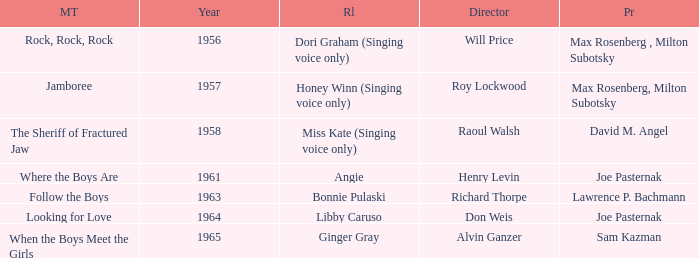What year was Sam Kazman a producer? 1965.0. 